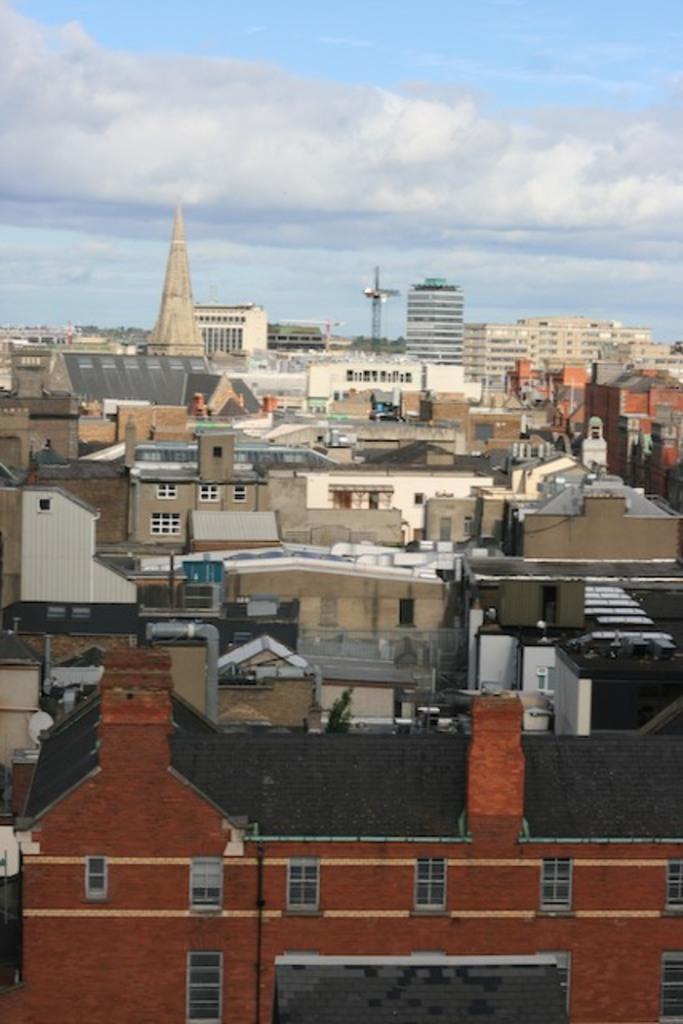In one or two sentences, can you explain what this image depicts? In this picture we can see buildings with windows, trees and some objects and in the background we can see the sky with clouds. 